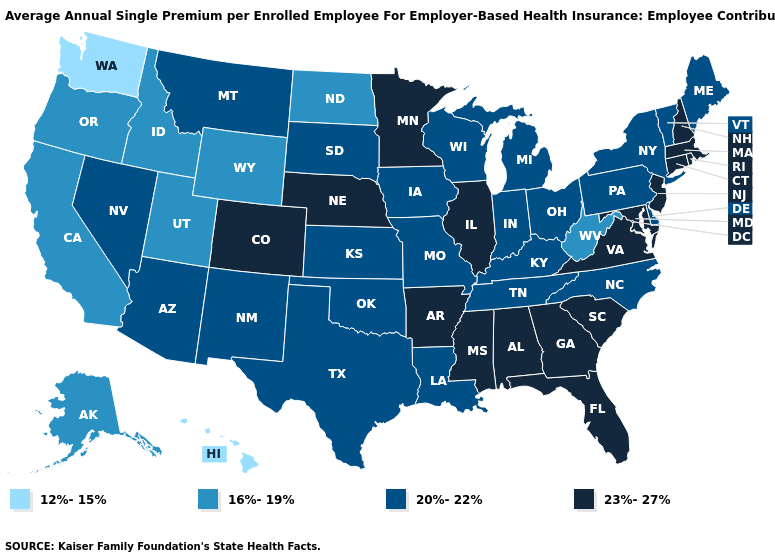What is the value of Maryland?
Be succinct. 23%-27%. What is the highest value in the USA?
Quick response, please. 23%-27%. Which states have the lowest value in the USA?
Concise answer only. Hawaii, Washington. What is the value of Rhode Island?
Keep it brief. 23%-27%. Does Louisiana have the same value as Ohio?
Answer briefly. Yes. What is the value of Kansas?
Answer briefly. 20%-22%. Is the legend a continuous bar?
Keep it brief. No. What is the value of South Dakota?
Concise answer only. 20%-22%. Which states have the highest value in the USA?
Be succinct. Alabama, Arkansas, Colorado, Connecticut, Florida, Georgia, Illinois, Maryland, Massachusetts, Minnesota, Mississippi, Nebraska, New Hampshire, New Jersey, Rhode Island, South Carolina, Virginia. Name the states that have a value in the range 12%-15%?
Answer briefly. Hawaii, Washington. Does the map have missing data?
Write a very short answer. No. Name the states that have a value in the range 16%-19%?
Be succinct. Alaska, California, Idaho, North Dakota, Oregon, Utah, West Virginia, Wyoming. What is the value of Michigan?
Quick response, please. 20%-22%. Name the states that have a value in the range 12%-15%?
Keep it brief. Hawaii, Washington. Among the states that border Idaho , does Utah have the highest value?
Keep it brief. No. 